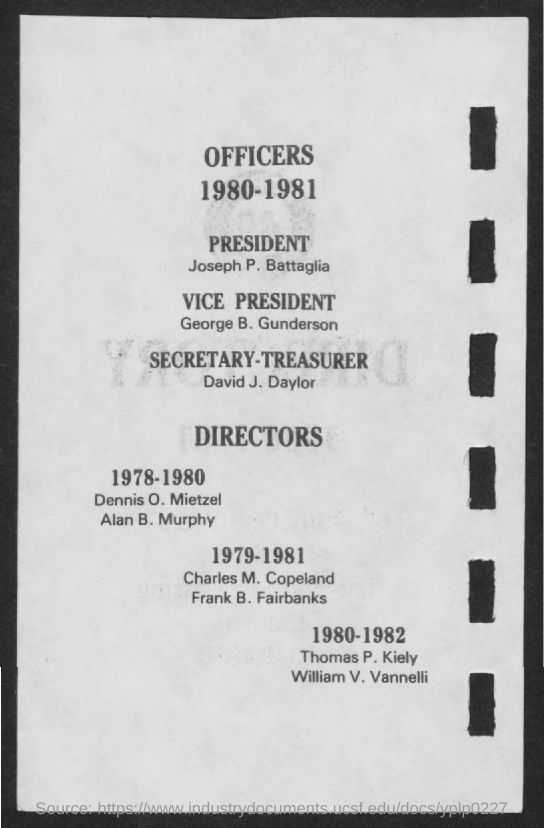Who is the President?
Offer a terse response. Joseph p. battaglia. Who is the Vice-President?
Offer a terse response. George B. Gunderson. Who is the Secretary-Treasurer?
Ensure brevity in your answer.  David J. Daylor. Dennis O. Mietzel and Alan B. Murphy are directors in which year?
Make the answer very short. 1978-1980. Charles M. Copeland and Frank B. Fairbanks are directors in which year?
Your answer should be very brief. 1979-1981. Thomas P. Kiely and William V. Vannelli are directors in which year?
Your answer should be very brief. 1980-1982. 